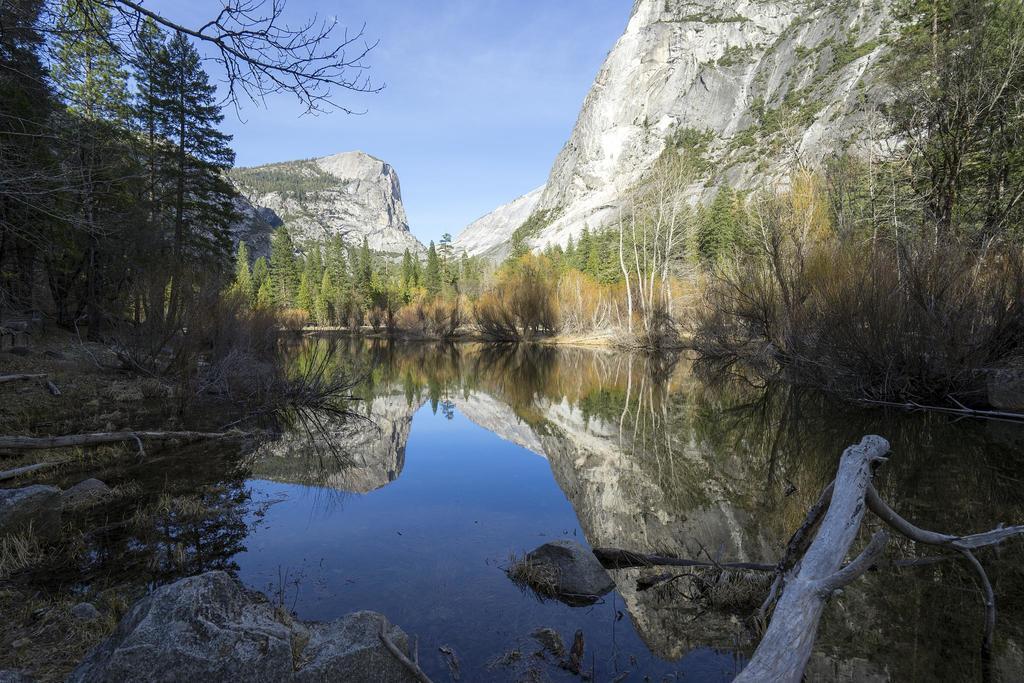Could you give a brief overview of what you see in this image? In this picture we can see water, beside the water we can see trees, rocks and we can see sky in the background. 